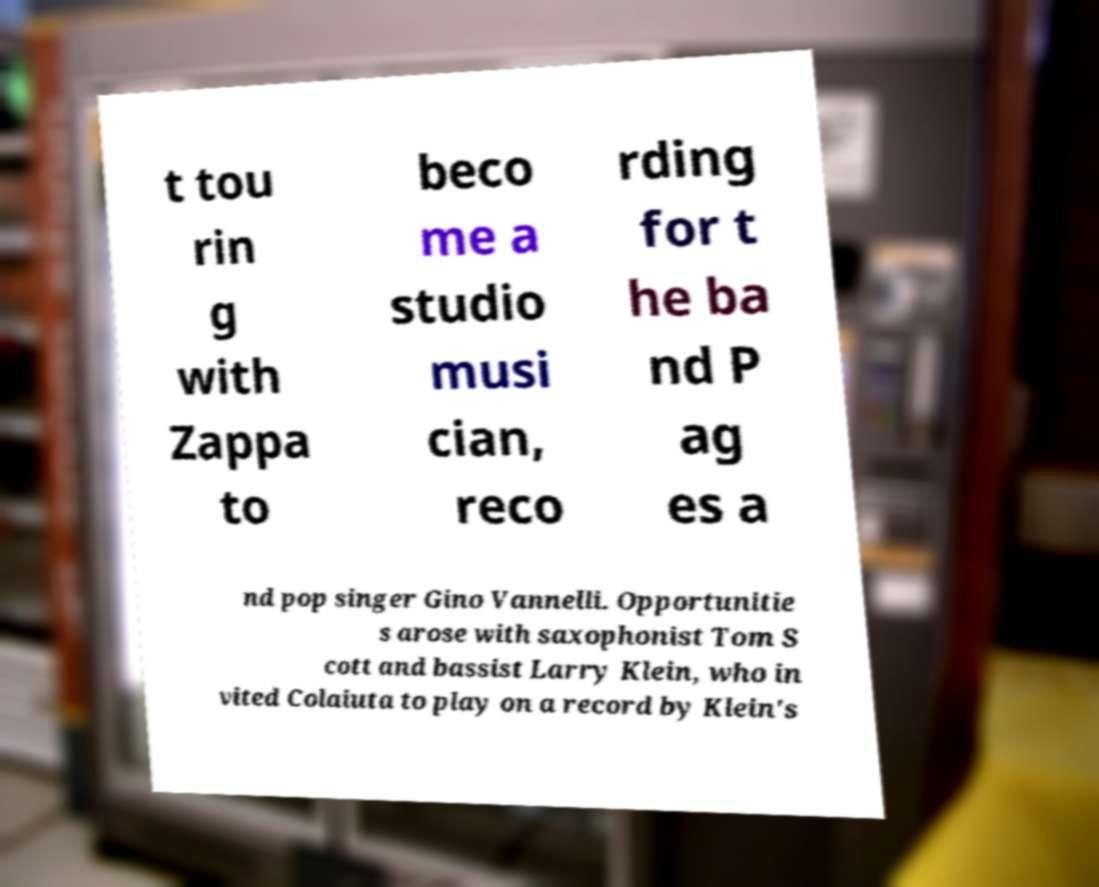Please identify and transcribe the text found in this image. t tou rin g with Zappa to beco me a studio musi cian, reco rding for t he ba nd P ag es a nd pop singer Gino Vannelli. Opportunitie s arose with saxophonist Tom S cott and bassist Larry Klein, who in vited Colaiuta to play on a record by Klein's 